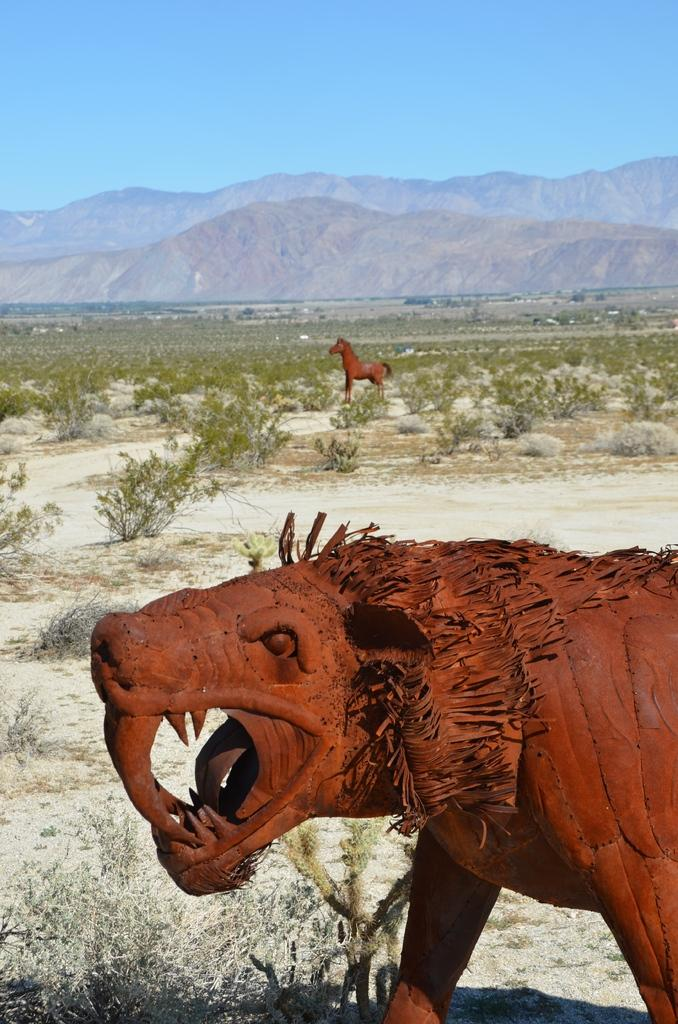What type of objects are depicted as statues in the image? There are statues of two animals in the image. What other natural elements can be seen in the image? There are plants, trees, and hills visible in the image. What is visible in the background of the image? The sky is visible in the background of the image. Where is the jar of pickles located in the image? There is no jar of pickles present in the image. Can you tell me how many family members are visible in the image? There are no family members depicted in the image. 